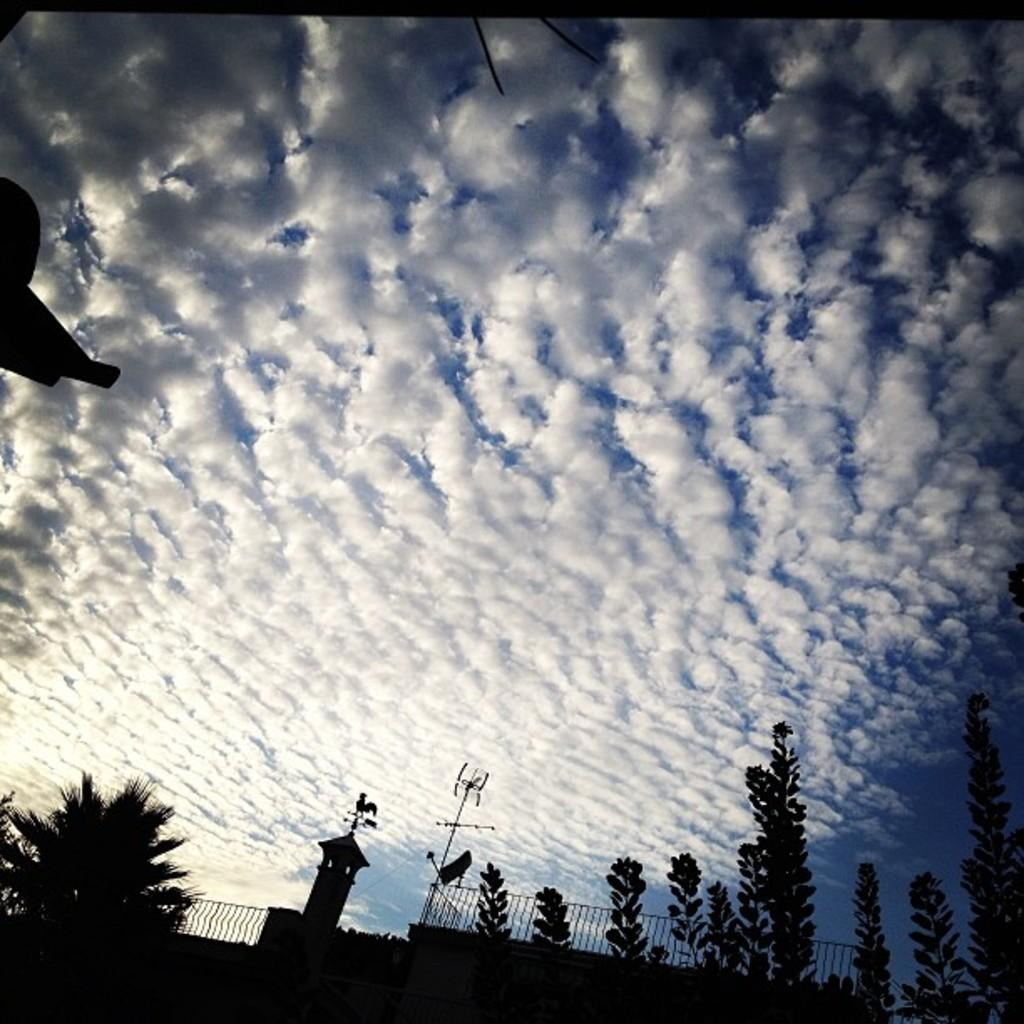What can be seen in the sky in the image? The sky with clouds is visible in the image. What type of vegetation is present in the image? There are trees in the image. What type of structure can be seen in the image? Iron grills are present in the image. What type of architectural feature is visible in the image? There is a wall in the image. Can you tell me how many animals are in the zoo in the image? There is no zoo present in the image, so it is not possible to determine the number of animals. 